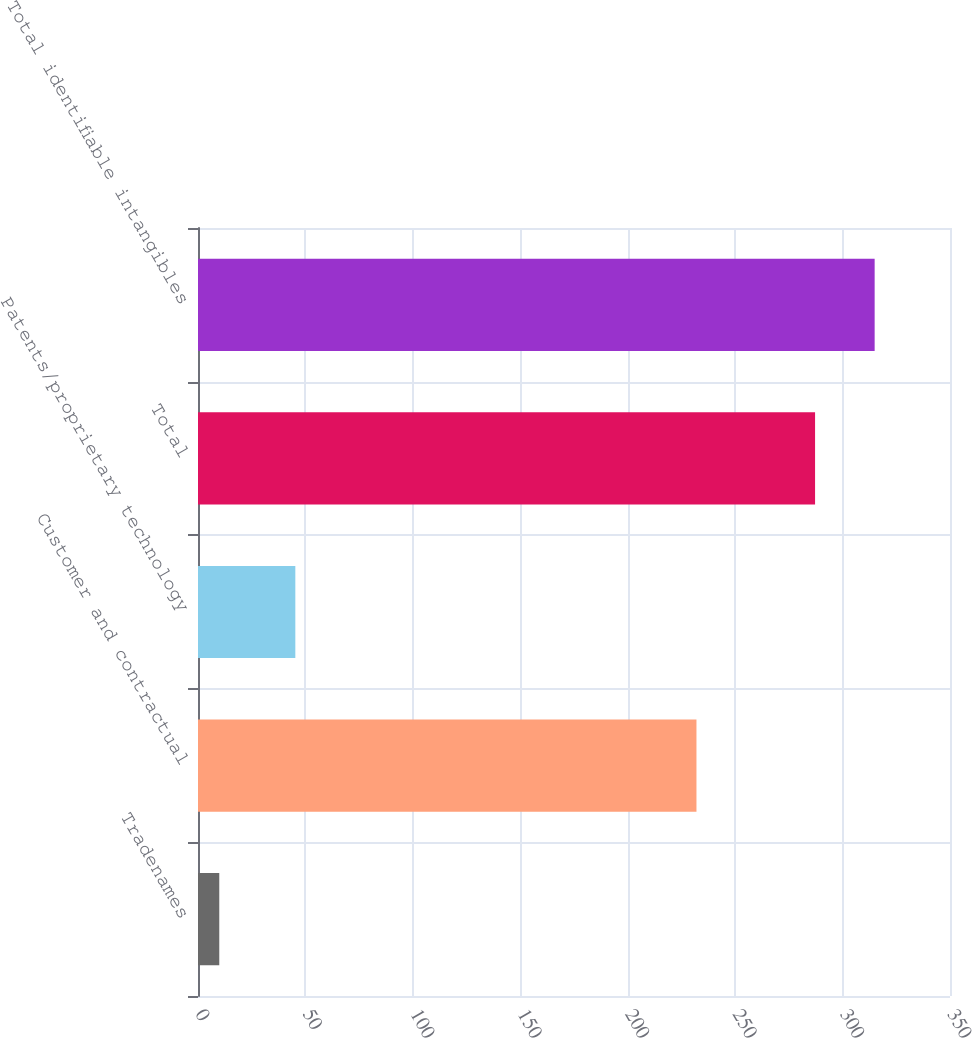Convert chart to OTSL. <chart><loc_0><loc_0><loc_500><loc_500><bar_chart><fcel>Tradenames<fcel>Customer and contractual<fcel>Patents/proprietary technology<fcel>Total<fcel>Total identifiable intangibles<nl><fcel>9.9<fcel>232<fcel>45.3<fcel>287.2<fcel>314.93<nl></chart> 